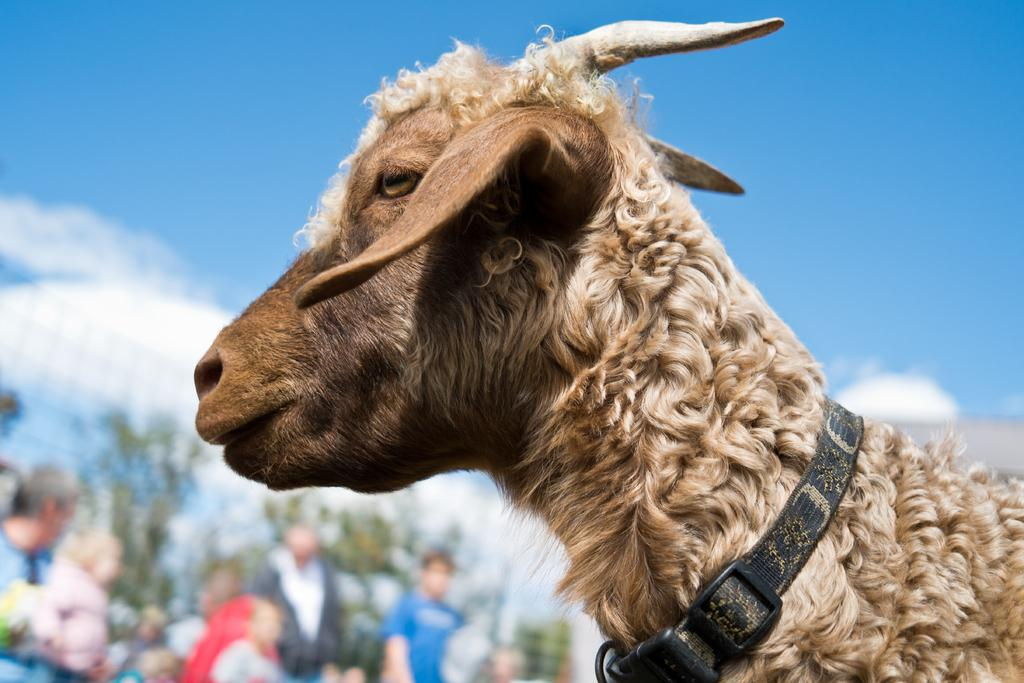What type of animal is in the image? There is an animal in the image, but the specific type cannot be determined from the provided facts. Where is the animal located in the image? The animal is in the front of the image. What is attached to the animal's neck? A belt is tied to the animal's neck. Can you describe the background of the image? The background of the image is blurred. What type of wrench is the animal using to fix the stove in the image? There is no wrench or stove present in the image; it only features an animal with a belt tied to its neck. 